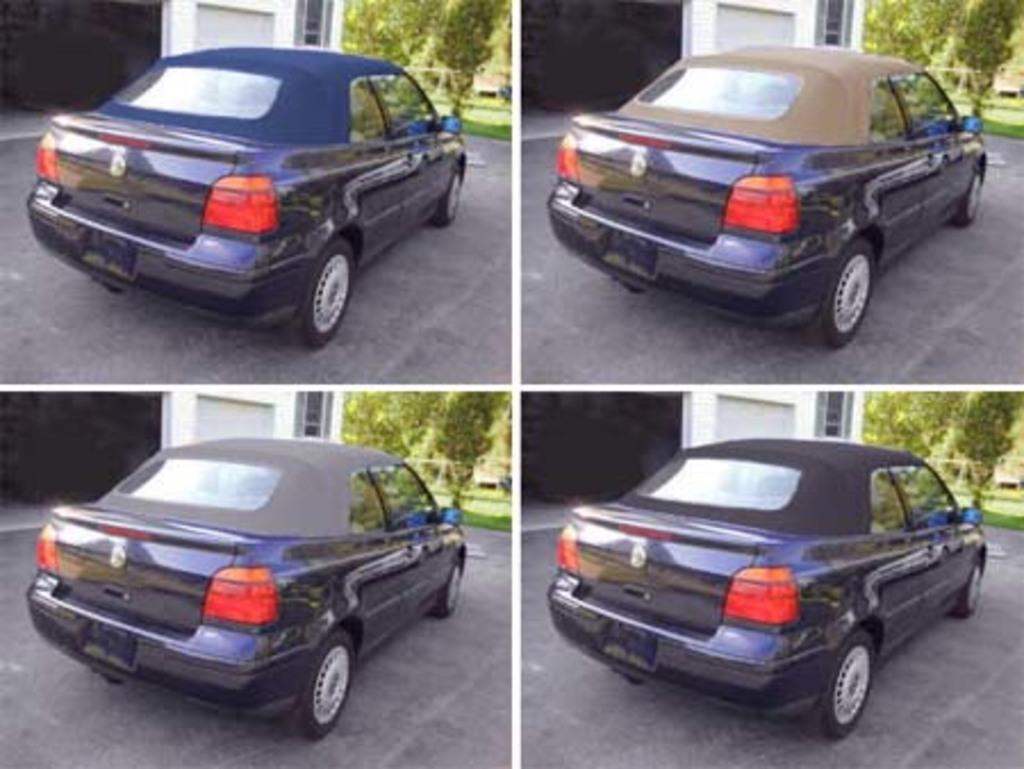Please provide a concise description of this image. It is a collage image. In this image there are cars. In front of the cars there are trees. Beside the cars there are walls. At the bottom of the images there is a road. 